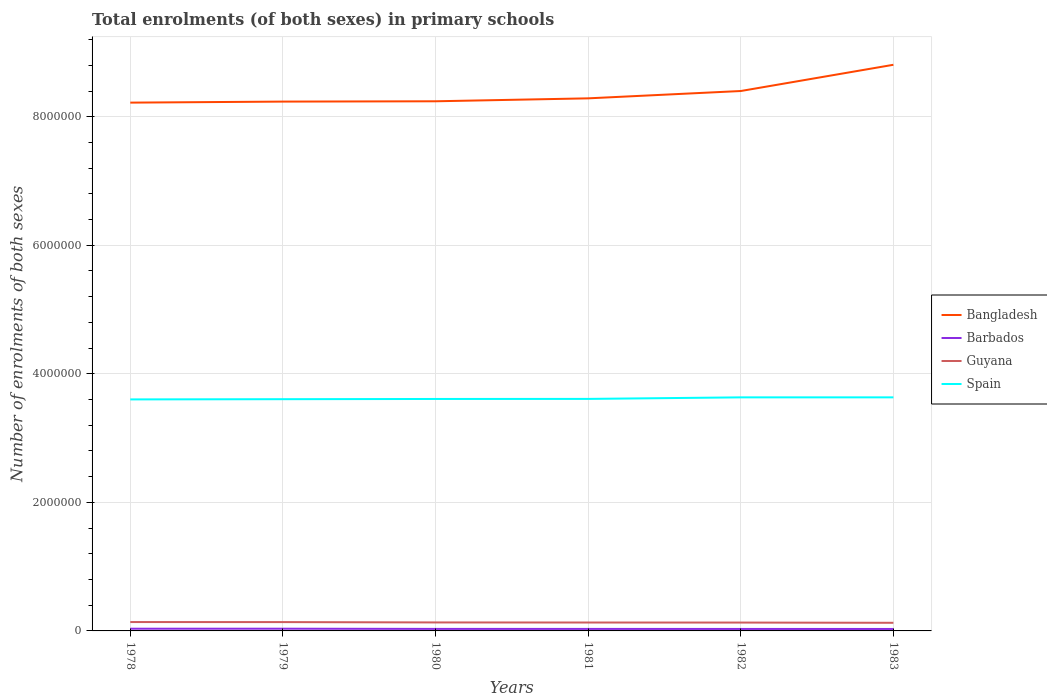Across all years, what is the maximum number of enrolments in primary schools in Spain?
Offer a terse response. 3.60e+06. In which year was the number of enrolments in primary schools in Barbados maximum?
Offer a very short reply. 1983. What is the total number of enrolments in primary schools in Barbados in the graph?
Offer a terse response. 810. What is the difference between the highest and the second highest number of enrolments in primary schools in Spain?
Keep it short and to the point. 3.20e+04. What is the difference between the highest and the lowest number of enrolments in primary schools in Barbados?
Offer a very short reply. 2. How many lines are there?
Provide a succinct answer. 4. How many years are there in the graph?
Your response must be concise. 6. What is the difference between two consecutive major ticks on the Y-axis?
Keep it short and to the point. 2.00e+06. Where does the legend appear in the graph?
Offer a very short reply. Center right. How are the legend labels stacked?
Keep it short and to the point. Vertical. What is the title of the graph?
Offer a very short reply. Total enrolments (of both sexes) in primary schools. Does "Myanmar" appear as one of the legend labels in the graph?
Your answer should be very brief. No. What is the label or title of the Y-axis?
Your answer should be compact. Number of enrolments of both sexes. What is the Number of enrolments of both sexes in Bangladesh in 1978?
Provide a succinct answer. 8.22e+06. What is the Number of enrolments of both sexes in Barbados in 1978?
Give a very brief answer. 3.43e+04. What is the Number of enrolments of both sexes of Guyana in 1978?
Keep it short and to the point. 1.38e+05. What is the Number of enrolments of both sexes in Spain in 1978?
Your answer should be very brief. 3.60e+06. What is the Number of enrolments of both sexes in Bangladesh in 1979?
Your answer should be very brief. 8.24e+06. What is the Number of enrolments of both sexes in Barbados in 1979?
Make the answer very short. 3.45e+04. What is the Number of enrolments of both sexes of Guyana in 1979?
Your response must be concise. 1.37e+05. What is the Number of enrolments of both sexes in Spain in 1979?
Offer a very short reply. 3.61e+06. What is the Number of enrolments of both sexes of Bangladesh in 1980?
Keep it short and to the point. 8.24e+06. What is the Number of enrolments of both sexes in Barbados in 1980?
Offer a terse response. 3.13e+04. What is the Number of enrolments of both sexes in Guyana in 1980?
Give a very brief answer. 1.32e+05. What is the Number of enrolments of both sexes in Spain in 1980?
Offer a terse response. 3.61e+06. What is the Number of enrolments of both sexes in Bangladesh in 1981?
Provide a short and direct response. 8.29e+06. What is the Number of enrolments of both sexes of Barbados in 1981?
Keep it short and to the point. 3.11e+04. What is the Number of enrolments of both sexes in Guyana in 1981?
Ensure brevity in your answer.  1.31e+05. What is the Number of enrolments of both sexes of Spain in 1981?
Keep it short and to the point. 3.61e+06. What is the Number of enrolments of both sexes in Bangladesh in 1982?
Your response must be concise. 8.40e+06. What is the Number of enrolments of both sexes in Barbados in 1982?
Keep it short and to the point. 3.07e+04. What is the Number of enrolments of both sexes of Guyana in 1982?
Provide a succinct answer. 1.30e+05. What is the Number of enrolments of both sexes in Spain in 1982?
Make the answer very short. 3.63e+06. What is the Number of enrolments of both sexes in Bangladesh in 1983?
Provide a succinct answer. 8.81e+06. What is the Number of enrolments of both sexes in Barbados in 1983?
Offer a very short reply. 3.03e+04. What is the Number of enrolments of both sexes in Guyana in 1983?
Keep it short and to the point. 1.26e+05. What is the Number of enrolments of both sexes in Spain in 1983?
Provide a succinct answer. 3.63e+06. Across all years, what is the maximum Number of enrolments of both sexes in Bangladesh?
Make the answer very short. 8.81e+06. Across all years, what is the maximum Number of enrolments of both sexes in Barbados?
Make the answer very short. 3.45e+04. Across all years, what is the maximum Number of enrolments of both sexes of Guyana?
Keep it short and to the point. 1.38e+05. Across all years, what is the maximum Number of enrolments of both sexes of Spain?
Give a very brief answer. 3.63e+06. Across all years, what is the minimum Number of enrolments of both sexes in Bangladesh?
Make the answer very short. 8.22e+06. Across all years, what is the minimum Number of enrolments of both sexes in Barbados?
Provide a short and direct response. 3.03e+04. Across all years, what is the minimum Number of enrolments of both sexes in Guyana?
Offer a terse response. 1.26e+05. Across all years, what is the minimum Number of enrolments of both sexes of Spain?
Your answer should be very brief. 3.60e+06. What is the total Number of enrolments of both sexes of Bangladesh in the graph?
Provide a short and direct response. 5.02e+07. What is the total Number of enrolments of both sexes in Barbados in the graph?
Offer a very short reply. 1.92e+05. What is the total Number of enrolments of both sexes in Guyana in the graph?
Your answer should be compact. 7.95e+05. What is the total Number of enrolments of both sexes in Spain in the graph?
Offer a very short reply. 2.17e+07. What is the difference between the Number of enrolments of both sexes of Bangladesh in 1978 and that in 1979?
Keep it short and to the point. -1.59e+04. What is the difference between the Number of enrolments of both sexes in Barbados in 1978 and that in 1979?
Offer a terse response. -212. What is the difference between the Number of enrolments of both sexes in Guyana in 1978 and that in 1979?
Keep it short and to the point. 832. What is the difference between the Number of enrolments of both sexes of Spain in 1978 and that in 1979?
Your answer should be very brief. -3376. What is the difference between the Number of enrolments of both sexes in Bangladesh in 1978 and that in 1980?
Your response must be concise. -2.09e+04. What is the difference between the Number of enrolments of both sexes in Barbados in 1978 and that in 1980?
Ensure brevity in your answer.  3025. What is the difference between the Number of enrolments of both sexes of Guyana in 1978 and that in 1980?
Offer a terse response. 6069. What is the difference between the Number of enrolments of both sexes in Spain in 1978 and that in 1980?
Your answer should be compact. -6906. What is the difference between the Number of enrolments of both sexes of Bangladesh in 1978 and that in 1981?
Your response must be concise. -6.65e+04. What is the difference between the Number of enrolments of both sexes of Barbados in 1978 and that in 1981?
Your answer should be very brief. 3177. What is the difference between the Number of enrolments of both sexes in Guyana in 1978 and that in 1981?
Offer a very short reply. 7312. What is the difference between the Number of enrolments of both sexes of Spain in 1978 and that in 1981?
Your answer should be compact. -7675. What is the difference between the Number of enrolments of both sexes of Bangladesh in 1978 and that in 1982?
Your response must be concise. -1.81e+05. What is the difference between the Number of enrolments of both sexes of Barbados in 1978 and that in 1982?
Your answer should be very brief. 3596. What is the difference between the Number of enrolments of both sexes of Guyana in 1978 and that in 1982?
Make the answer very short. 8141. What is the difference between the Number of enrolments of both sexes of Spain in 1978 and that in 1982?
Your response must be concise. -3.18e+04. What is the difference between the Number of enrolments of both sexes in Bangladesh in 1978 and that in 1983?
Provide a short and direct response. -5.89e+05. What is the difference between the Number of enrolments of both sexes in Barbados in 1978 and that in 1983?
Offer a terse response. 3987. What is the difference between the Number of enrolments of both sexes of Guyana in 1978 and that in 1983?
Provide a short and direct response. 1.18e+04. What is the difference between the Number of enrolments of both sexes of Spain in 1978 and that in 1983?
Make the answer very short. -3.20e+04. What is the difference between the Number of enrolments of both sexes of Bangladesh in 1979 and that in 1980?
Ensure brevity in your answer.  -4932. What is the difference between the Number of enrolments of both sexes in Barbados in 1979 and that in 1980?
Offer a terse response. 3237. What is the difference between the Number of enrolments of both sexes of Guyana in 1979 and that in 1980?
Provide a succinct answer. 5237. What is the difference between the Number of enrolments of both sexes of Spain in 1979 and that in 1980?
Offer a very short reply. -3530. What is the difference between the Number of enrolments of both sexes of Bangladesh in 1979 and that in 1981?
Provide a succinct answer. -5.06e+04. What is the difference between the Number of enrolments of both sexes in Barbados in 1979 and that in 1981?
Your answer should be very brief. 3389. What is the difference between the Number of enrolments of both sexes in Guyana in 1979 and that in 1981?
Your answer should be compact. 6480. What is the difference between the Number of enrolments of both sexes of Spain in 1979 and that in 1981?
Give a very brief answer. -4299. What is the difference between the Number of enrolments of both sexes of Bangladesh in 1979 and that in 1982?
Your answer should be compact. -1.65e+05. What is the difference between the Number of enrolments of both sexes of Barbados in 1979 and that in 1982?
Provide a succinct answer. 3808. What is the difference between the Number of enrolments of both sexes in Guyana in 1979 and that in 1982?
Ensure brevity in your answer.  7309. What is the difference between the Number of enrolments of both sexes in Spain in 1979 and that in 1982?
Give a very brief answer. -2.84e+04. What is the difference between the Number of enrolments of both sexes in Bangladesh in 1979 and that in 1983?
Your answer should be compact. -5.73e+05. What is the difference between the Number of enrolments of both sexes of Barbados in 1979 and that in 1983?
Your answer should be very brief. 4199. What is the difference between the Number of enrolments of both sexes in Guyana in 1979 and that in 1983?
Your answer should be very brief. 1.09e+04. What is the difference between the Number of enrolments of both sexes of Spain in 1979 and that in 1983?
Your answer should be very brief. -2.86e+04. What is the difference between the Number of enrolments of both sexes of Bangladesh in 1980 and that in 1981?
Provide a succinct answer. -4.56e+04. What is the difference between the Number of enrolments of both sexes of Barbados in 1980 and that in 1981?
Give a very brief answer. 152. What is the difference between the Number of enrolments of both sexes of Guyana in 1980 and that in 1981?
Offer a terse response. 1243. What is the difference between the Number of enrolments of both sexes of Spain in 1980 and that in 1981?
Provide a succinct answer. -769. What is the difference between the Number of enrolments of both sexes of Bangladesh in 1980 and that in 1982?
Keep it short and to the point. -1.60e+05. What is the difference between the Number of enrolments of both sexes in Barbados in 1980 and that in 1982?
Make the answer very short. 571. What is the difference between the Number of enrolments of both sexes in Guyana in 1980 and that in 1982?
Ensure brevity in your answer.  2072. What is the difference between the Number of enrolments of both sexes in Spain in 1980 and that in 1982?
Give a very brief answer. -2.49e+04. What is the difference between the Number of enrolments of both sexes in Bangladesh in 1980 and that in 1983?
Offer a very short reply. -5.68e+05. What is the difference between the Number of enrolments of both sexes of Barbados in 1980 and that in 1983?
Your response must be concise. 962. What is the difference between the Number of enrolments of both sexes of Guyana in 1980 and that in 1983?
Offer a very short reply. 5703. What is the difference between the Number of enrolments of both sexes in Spain in 1980 and that in 1983?
Your response must be concise. -2.51e+04. What is the difference between the Number of enrolments of both sexes in Bangladesh in 1981 and that in 1982?
Ensure brevity in your answer.  -1.14e+05. What is the difference between the Number of enrolments of both sexes of Barbados in 1981 and that in 1982?
Offer a very short reply. 419. What is the difference between the Number of enrolments of both sexes in Guyana in 1981 and that in 1982?
Keep it short and to the point. 829. What is the difference between the Number of enrolments of both sexes of Spain in 1981 and that in 1982?
Provide a succinct answer. -2.41e+04. What is the difference between the Number of enrolments of both sexes of Bangladesh in 1981 and that in 1983?
Make the answer very short. -5.22e+05. What is the difference between the Number of enrolments of both sexes in Barbados in 1981 and that in 1983?
Provide a short and direct response. 810. What is the difference between the Number of enrolments of both sexes of Guyana in 1981 and that in 1983?
Make the answer very short. 4460. What is the difference between the Number of enrolments of both sexes of Spain in 1981 and that in 1983?
Your response must be concise. -2.43e+04. What is the difference between the Number of enrolments of both sexes of Bangladesh in 1982 and that in 1983?
Keep it short and to the point. -4.08e+05. What is the difference between the Number of enrolments of both sexes in Barbados in 1982 and that in 1983?
Make the answer very short. 391. What is the difference between the Number of enrolments of both sexes of Guyana in 1982 and that in 1983?
Provide a short and direct response. 3631. What is the difference between the Number of enrolments of both sexes in Spain in 1982 and that in 1983?
Keep it short and to the point. -193. What is the difference between the Number of enrolments of both sexes of Bangladesh in 1978 and the Number of enrolments of both sexes of Barbados in 1979?
Keep it short and to the point. 8.18e+06. What is the difference between the Number of enrolments of both sexes of Bangladesh in 1978 and the Number of enrolments of both sexes of Guyana in 1979?
Offer a very short reply. 8.08e+06. What is the difference between the Number of enrolments of both sexes in Bangladesh in 1978 and the Number of enrolments of both sexes in Spain in 1979?
Give a very brief answer. 4.61e+06. What is the difference between the Number of enrolments of both sexes of Barbados in 1978 and the Number of enrolments of both sexes of Guyana in 1979?
Give a very brief answer. -1.03e+05. What is the difference between the Number of enrolments of both sexes in Barbados in 1978 and the Number of enrolments of both sexes in Spain in 1979?
Offer a terse response. -3.57e+06. What is the difference between the Number of enrolments of both sexes in Guyana in 1978 and the Number of enrolments of both sexes in Spain in 1979?
Give a very brief answer. -3.47e+06. What is the difference between the Number of enrolments of both sexes in Bangladesh in 1978 and the Number of enrolments of both sexes in Barbados in 1980?
Keep it short and to the point. 8.19e+06. What is the difference between the Number of enrolments of both sexes in Bangladesh in 1978 and the Number of enrolments of both sexes in Guyana in 1980?
Provide a succinct answer. 8.09e+06. What is the difference between the Number of enrolments of both sexes of Bangladesh in 1978 and the Number of enrolments of both sexes of Spain in 1980?
Give a very brief answer. 4.61e+06. What is the difference between the Number of enrolments of both sexes in Barbados in 1978 and the Number of enrolments of both sexes in Guyana in 1980?
Provide a short and direct response. -9.78e+04. What is the difference between the Number of enrolments of both sexes of Barbados in 1978 and the Number of enrolments of both sexes of Spain in 1980?
Ensure brevity in your answer.  -3.57e+06. What is the difference between the Number of enrolments of both sexes of Guyana in 1978 and the Number of enrolments of both sexes of Spain in 1980?
Ensure brevity in your answer.  -3.47e+06. What is the difference between the Number of enrolments of both sexes in Bangladesh in 1978 and the Number of enrolments of both sexes in Barbados in 1981?
Keep it short and to the point. 8.19e+06. What is the difference between the Number of enrolments of both sexes of Bangladesh in 1978 and the Number of enrolments of both sexes of Guyana in 1981?
Your answer should be compact. 8.09e+06. What is the difference between the Number of enrolments of both sexes of Bangladesh in 1978 and the Number of enrolments of both sexes of Spain in 1981?
Your answer should be very brief. 4.61e+06. What is the difference between the Number of enrolments of both sexes in Barbados in 1978 and the Number of enrolments of both sexes in Guyana in 1981?
Ensure brevity in your answer.  -9.65e+04. What is the difference between the Number of enrolments of both sexes in Barbados in 1978 and the Number of enrolments of both sexes in Spain in 1981?
Provide a short and direct response. -3.58e+06. What is the difference between the Number of enrolments of both sexes of Guyana in 1978 and the Number of enrolments of both sexes of Spain in 1981?
Your answer should be very brief. -3.47e+06. What is the difference between the Number of enrolments of both sexes of Bangladesh in 1978 and the Number of enrolments of both sexes of Barbados in 1982?
Your answer should be very brief. 8.19e+06. What is the difference between the Number of enrolments of both sexes of Bangladesh in 1978 and the Number of enrolments of both sexes of Guyana in 1982?
Keep it short and to the point. 8.09e+06. What is the difference between the Number of enrolments of both sexes in Bangladesh in 1978 and the Number of enrolments of both sexes in Spain in 1982?
Offer a very short reply. 4.59e+06. What is the difference between the Number of enrolments of both sexes in Barbados in 1978 and the Number of enrolments of both sexes in Guyana in 1982?
Your response must be concise. -9.57e+04. What is the difference between the Number of enrolments of both sexes of Barbados in 1978 and the Number of enrolments of both sexes of Spain in 1982?
Offer a terse response. -3.60e+06. What is the difference between the Number of enrolments of both sexes in Guyana in 1978 and the Number of enrolments of both sexes in Spain in 1982?
Provide a succinct answer. -3.50e+06. What is the difference between the Number of enrolments of both sexes of Bangladesh in 1978 and the Number of enrolments of both sexes of Barbados in 1983?
Give a very brief answer. 8.19e+06. What is the difference between the Number of enrolments of both sexes in Bangladesh in 1978 and the Number of enrolments of both sexes in Guyana in 1983?
Your answer should be compact. 8.09e+06. What is the difference between the Number of enrolments of both sexes of Bangladesh in 1978 and the Number of enrolments of both sexes of Spain in 1983?
Offer a terse response. 4.59e+06. What is the difference between the Number of enrolments of both sexes in Barbados in 1978 and the Number of enrolments of both sexes in Guyana in 1983?
Your answer should be very brief. -9.20e+04. What is the difference between the Number of enrolments of both sexes in Barbados in 1978 and the Number of enrolments of both sexes in Spain in 1983?
Your answer should be compact. -3.60e+06. What is the difference between the Number of enrolments of both sexes in Guyana in 1978 and the Number of enrolments of both sexes in Spain in 1983?
Offer a terse response. -3.50e+06. What is the difference between the Number of enrolments of both sexes in Bangladesh in 1979 and the Number of enrolments of both sexes in Barbados in 1980?
Offer a very short reply. 8.20e+06. What is the difference between the Number of enrolments of both sexes in Bangladesh in 1979 and the Number of enrolments of both sexes in Guyana in 1980?
Provide a short and direct response. 8.10e+06. What is the difference between the Number of enrolments of both sexes in Bangladesh in 1979 and the Number of enrolments of both sexes in Spain in 1980?
Your answer should be compact. 4.63e+06. What is the difference between the Number of enrolments of both sexes in Barbados in 1979 and the Number of enrolments of both sexes in Guyana in 1980?
Offer a terse response. -9.75e+04. What is the difference between the Number of enrolments of both sexes of Barbados in 1979 and the Number of enrolments of both sexes of Spain in 1980?
Your answer should be very brief. -3.57e+06. What is the difference between the Number of enrolments of both sexes in Guyana in 1979 and the Number of enrolments of both sexes in Spain in 1980?
Provide a succinct answer. -3.47e+06. What is the difference between the Number of enrolments of both sexes of Bangladesh in 1979 and the Number of enrolments of both sexes of Barbados in 1981?
Your response must be concise. 8.20e+06. What is the difference between the Number of enrolments of both sexes of Bangladesh in 1979 and the Number of enrolments of both sexes of Guyana in 1981?
Your answer should be very brief. 8.10e+06. What is the difference between the Number of enrolments of both sexes in Bangladesh in 1979 and the Number of enrolments of both sexes in Spain in 1981?
Your answer should be very brief. 4.63e+06. What is the difference between the Number of enrolments of both sexes in Barbados in 1979 and the Number of enrolments of both sexes in Guyana in 1981?
Give a very brief answer. -9.63e+04. What is the difference between the Number of enrolments of both sexes in Barbados in 1979 and the Number of enrolments of both sexes in Spain in 1981?
Provide a short and direct response. -3.58e+06. What is the difference between the Number of enrolments of both sexes of Guyana in 1979 and the Number of enrolments of both sexes of Spain in 1981?
Offer a very short reply. -3.47e+06. What is the difference between the Number of enrolments of both sexes of Bangladesh in 1979 and the Number of enrolments of both sexes of Barbados in 1982?
Offer a very short reply. 8.20e+06. What is the difference between the Number of enrolments of both sexes of Bangladesh in 1979 and the Number of enrolments of both sexes of Guyana in 1982?
Your answer should be compact. 8.11e+06. What is the difference between the Number of enrolments of both sexes of Bangladesh in 1979 and the Number of enrolments of both sexes of Spain in 1982?
Provide a short and direct response. 4.60e+06. What is the difference between the Number of enrolments of both sexes in Barbados in 1979 and the Number of enrolments of both sexes in Guyana in 1982?
Offer a very short reply. -9.55e+04. What is the difference between the Number of enrolments of both sexes in Barbados in 1979 and the Number of enrolments of both sexes in Spain in 1982?
Give a very brief answer. -3.60e+06. What is the difference between the Number of enrolments of both sexes in Guyana in 1979 and the Number of enrolments of both sexes in Spain in 1982?
Ensure brevity in your answer.  -3.50e+06. What is the difference between the Number of enrolments of both sexes of Bangladesh in 1979 and the Number of enrolments of both sexes of Barbados in 1983?
Your answer should be compact. 8.20e+06. What is the difference between the Number of enrolments of both sexes in Bangladesh in 1979 and the Number of enrolments of both sexes in Guyana in 1983?
Your response must be concise. 8.11e+06. What is the difference between the Number of enrolments of both sexes in Bangladesh in 1979 and the Number of enrolments of both sexes in Spain in 1983?
Offer a terse response. 4.60e+06. What is the difference between the Number of enrolments of both sexes in Barbados in 1979 and the Number of enrolments of both sexes in Guyana in 1983?
Ensure brevity in your answer.  -9.18e+04. What is the difference between the Number of enrolments of both sexes in Barbados in 1979 and the Number of enrolments of both sexes in Spain in 1983?
Keep it short and to the point. -3.60e+06. What is the difference between the Number of enrolments of both sexes in Guyana in 1979 and the Number of enrolments of both sexes in Spain in 1983?
Your answer should be very brief. -3.50e+06. What is the difference between the Number of enrolments of both sexes in Bangladesh in 1980 and the Number of enrolments of both sexes in Barbados in 1981?
Provide a short and direct response. 8.21e+06. What is the difference between the Number of enrolments of both sexes of Bangladesh in 1980 and the Number of enrolments of both sexes of Guyana in 1981?
Your answer should be compact. 8.11e+06. What is the difference between the Number of enrolments of both sexes of Bangladesh in 1980 and the Number of enrolments of both sexes of Spain in 1981?
Your answer should be very brief. 4.63e+06. What is the difference between the Number of enrolments of both sexes of Barbados in 1980 and the Number of enrolments of both sexes of Guyana in 1981?
Make the answer very short. -9.95e+04. What is the difference between the Number of enrolments of both sexes in Barbados in 1980 and the Number of enrolments of both sexes in Spain in 1981?
Provide a short and direct response. -3.58e+06. What is the difference between the Number of enrolments of both sexes of Guyana in 1980 and the Number of enrolments of both sexes of Spain in 1981?
Your answer should be compact. -3.48e+06. What is the difference between the Number of enrolments of both sexes of Bangladesh in 1980 and the Number of enrolments of both sexes of Barbados in 1982?
Your answer should be compact. 8.21e+06. What is the difference between the Number of enrolments of both sexes in Bangladesh in 1980 and the Number of enrolments of both sexes in Guyana in 1982?
Give a very brief answer. 8.11e+06. What is the difference between the Number of enrolments of both sexes in Bangladesh in 1980 and the Number of enrolments of both sexes in Spain in 1982?
Make the answer very short. 4.61e+06. What is the difference between the Number of enrolments of both sexes of Barbados in 1980 and the Number of enrolments of both sexes of Guyana in 1982?
Give a very brief answer. -9.87e+04. What is the difference between the Number of enrolments of both sexes of Barbados in 1980 and the Number of enrolments of both sexes of Spain in 1982?
Provide a short and direct response. -3.60e+06. What is the difference between the Number of enrolments of both sexes in Guyana in 1980 and the Number of enrolments of both sexes in Spain in 1982?
Provide a short and direct response. -3.50e+06. What is the difference between the Number of enrolments of both sexes of Bangladesh in 1980 and the Number of enrolments of both sexes of Barbados in 1983?
Ensure brevity in your answer.  8.21e+06. What is the difference between the Number of enrolments of both sexes of Bangladesh in 1980 and the Number of enrolments of both sexes of Guyana in 1983?
Ensure brevity in your answer.  8.11e+06. What is the difference between the Number of enrolments of both sexes in Bangladesh in 1980 and the Number of enrolments of both sexes in Spain in 1983?
Offer a terse response. 4.61e+06. What is the difference between the Number of enrolments of both sexes in Barbados in 1980 and the Number of enrolments of both sexes in Guyana in 1983?
Provide a succinct answer. -9.51e+04. What is the difference between the Number of enrolments of both sexes in Barbados in 1980 and the Number of enrolments of both sexes in Spain in 1983?
Your answer should be compact. -3.60e+06. What is the difference between the Number of enrolments of both sexes of Guyana in 1980 and the Number of enrolments of both sexes of Spain in 1983?
Offer a very short reply. -3.50e+06. What is the difference between the Number of enrolments of both sexes in Bangladesh in 1981 and the Number of enrolments of both sexes in Barbados in 1982?
Your response must be concise. 8.26e+06. What is the difference between the Number of enrolments of both sexes in Bangladesh in 1981 and the Number of enrolments of both sexes in Guyana in 1982?
Offer a terse response. 8.16e+06. What is the difference between the Number of enrolments of both sexes of Bangladesh in 1981 and the Number of enrolments of both sexes of Spain in 1982?
Your answer should be compact. 4.65e+06. What is the difference between the Number of enrolments of both sexes in Barbados in 1981 and the Number of enrolments of both sexes in Guyana in 1982?
Your answer should be very brief. -9.89e+04. What is the difference between the Number of enrolments of both sexes of Barbados in 1981 and the Number of enrolments of both sexes of Spain in 1982?
Offer a very short reply. -3.60e+06. What is the difference between the Number of enrolments of both sexes of Guyana in 1981 and the Number of enrolments of both sexes of Spain in 1982?
Make the answer very short. -3.50e+06. What is the difference between the Number of enrolments of both sexes of Bangladesh in 1981 and the Number of enrolments of both sexes of Barbados in 1983?
Provide a short and direct response. 8.26e+06. What is the difference between the Number of enrolments of both sexes in Bangladesh in 1981 and the Number of enrolments of both sexes in Guyana in 1983?
Give a very brief answer. 8.16e+06. What is the difference between the Number of enrolments of both sexes in Bangladesh in 1981 and the Number of enrolments of both sexes in Spain in 1983?
Keep it short and to the point. 4.65e+06. What is the difference between the Number of enrolments of both sexes in Barbados in 1981 and the Number of enrolments of both sexes in Guyana in 1983?
Make the answer very short. -9.52e+04. What is the difference between the Number of enrolments of both sexes of Barbados in 1981 and the Number of enrolments of both sexes of Spain in 1983?
Your answer should be compact. -3.60e+06. What is the difference between the Number of enrolments of both sexes of Guyana in 1981 and the Number of enrolments of both sexes of Spain in 1983?
Make the answer very short. -3.50e+06. What is the difference between the Number of enrolments of both sexes in Bangladesh in 1982 and the Number of enrolments of both sexes in Barbados in 1983?
Your answer should be compact. 8.37e+06. What is the difference between the Number of enrolments of both sexes of Bangladesh in 1982 and the Number of enrolments of both sexes of Guyana in 1983?
Keep it short and to the point. 8.27e+06. What is the difference between the Number of enrolments of both sexes in Bangladesh in 1982 and the Number of enrolments of both sexes in Spain in 1983?
Keep it short and to the point. 4.77e+06. What is the difference between the Number of enrolments of both sexes in Barbados in 1982 and the Number of enrolments of both sexes in Guyana in 1983?
Keep it short and to the point. -9.56e+04. What is the difference between the Number of enrolments of both sexes in Barbados in 1982 and the Number of enrolments of both sexes in Spain in 1983?
Keep it short and to the point. -3.60e+06. What is the difference between the Number of enrolments of both sexes of Guyana in 1982 and the Number of enrolments of both sexes of Spain in 1983?
Make the answer very short. -3.50e+06. What is the average Number of enrolments of both sexes in Bangladesh per year?
Give a very brief answer. 8.36e+06. What is the average Number of enrolments of both sexes in Barbados per year?
Offer a terse response. 3.21e+04. What is the average Number of enrolments of both sexes of Guyana per year?
Provide a succinct answer. 1.32e+05. What is the average Number of enrolments of both sexes in Spain per year?
Provide a short and direct response. 3.62e+06. In the year 1978, what is the difference between the Number of enrolments of both sexes of Bangladesh and Number of enrolments of both sexes of Barbados?
Ensure brevity in your answer.  8.18e+06. In the year 1978, what is the difference between the Number of enrolments of both sexes in Bangladesh and Number of enrolments of both sexes in Guyana?
Keep it short and to the point. 8.08e+06. In the year 1978, what is the difference between the Number of enrolments of both sexes of Bangladesh and Number of enrolments of both sexes of Spain?
Offer a very short reply. 4.62e+06. In the year 1978, what is the difference between the Number of enrolments of both sexes of Barbados and Number of enrolments of both sexes of Guyana?
Your response must be concise. -1.04e+05. In the year 1978, what is the difference between the Number of enrolments of both sexes in Barbados and Number of enrolments of both sexes in Spain?
Provide a succinct answer. -3.57e+06. In the year 1978, what is the difference between the Number of enrolments of both sexes of Guyana and Number of enrolments of both sexes of Spain?
Your response must be concise. -3.46e+06. In the year 1979, what is the difference between the Number of enrolments of both sexes in Bangladesh and Number of enrolments of both sexes in Barbados?
Your answer should be very brief. 8.20e+06. In the year 1979, what is the difference between the Number of enrolments of both sexes of Bangladesh and Number of enrolments of both sexes of Guyana?
Give a very brief answer. 8.10e+06. In the year 1979, what is the difference between the Number of enrolments of both sexes of Bangladesh and Number of enrolments of both sexes of Spain?
Your answer should be compact. 4.63e+06. In the year 1979, what is the difference between the Number of enrolments of both sexes in Barbados and Number of enrolments of both sexes in Guyana?
Make the answer very short. -1.03e+05. In the year 1979, what is the difference between the Number of enrolments of both sexes of Barbados and Number of enrolments of both sexes of Spain?
Provide a short and direct response. -3.57e+06. In the year 1979, what is the difference between the Number of enrolments of both sexes in Guyana and Number of enrolments of both sexes in Spain?
Your response must be concise. -3.47e+06. In the year 1980, what is the difference between the Number of enrolments of both sexes in Bangladesh and Number of enrolments of both sexes in Barbados?
Your answer should be compact. 8.21e+06. In the year 1980, what is the difference between the Number of enrolments of both sexes in Bangladesh and Number of enrolments of both sexes in Guyana?
Give a very brief answer. 8.11e+06. In the year 1980, what is the difference between the Number of enrolments of both sexes in Bangladesh and Number of enrolments of both sexes in Spain?
Offer a terse response. 4.63e+06. In the year 1980, what is the difference between the Number of enrolments of both sexes in Barbados and Number of enrolments of both sexes in Guyana?
Your answer should be compact. -1.01e+05. In the year 1980, what is the difference between the Number of enrolments of both sexes of Barbados and Number of enrolments of both sexes of Spain?
Give a very brief answer. -3.58e+06. In the year 1980, what is the difference between the Number of enrolments of both sexes in Guyana and Number of enrolments of both sexes in Spain?
Give a very brief answer. -3.48e+06. In the year 1981, what is the difference between the Number of enrolments of both sexes in Bangladesh and Number of enrolments of both sexes in Barbados?
Provide a succinct answer. 8.25e+06. In the year 1981, what is the difference between the Number of enrolments of both sexes of Bangladesh and Number of enrolments of both sexes of Guyana?
Your answer should be very brief. 8.15e+06. In the year 1981, what is the difference between the Number of enrolments of both sexes of Bangladesh and Number of enrolments of both sexes of Spain?
Provide a short and direct response. 4.68e+06. In the year 1981, what is the difference between the Number of enrolments of both sexes in Barbados and Number of enrolments of both sexes in Guyana?
Provide a succinct answer. -9.97e+04. In the year 1981, what is the difference between the Number of enrolments of both sexes in Barbados and Number of enrolments of both sexes in Spain?
Provide a short and direct response. -3.58e+06. In the year 1981, what is the difference between the Number of enrolments of both sexes of Guyana and Number of enrolments of both sexes of Spain?
Your answer should be very brief. -3.48e+06. In the year 1982, what is the difference between the Number of enrolments of both sexes in Bangladesh and Number of enrolments of both sexes in Barbados?
Offer a very short reply. 8.37e+06. In the year 1982, what is the difference between the Number of enrolments of both sexes of Bangladesh and Number of enrolments of both sexes of Guyana?
Offer a very short reply. 8.27e+06. In the year 1982, what is the difference between the Number of enrolments of both sexes in Bangladesh and Number of enrolments of both sexes in Spain?
Your answer should be very brief. 4.77e+06. In the year 1982, what is the difference between the Number of enrolments of both sexes of Barbados and Number of enrolments of both sexes of Guyana?
Provide a short and direct response. -9.93e+04. In the year 1982, what is the difference between the Number of enrolments of both sexes in Barbados and Number of enrolments of both sexes in Spain?
Give a very brief answer. -3.60e+06. In the year 1982, what is the difference between the Number of enrolments of both sexes in Guyana and Number of enrolments of both sexes in Spain?
Provide a succinct answer. -3.50e+06. In the year 1983, what is the difference between the Number of enrolments of both sexes in Bangladesh and Number of enrolments of both sexes in Barbados?
Offer a terse response. 8.78e+06. In the year 1983, what is the difference between the Number of enrolments of both sexes in Bangladesh and Number of enrolments of both sexes in Guyana?
Provide a succinct answer. 8.68e+06. In the year 1983, what is the difference between the Number of enrolments of both sexes in Bangladesh and Number of enrolments of both sexes in Spain?
Provide a succinct answer. 5.17e+06. In the year 1983, what is the difference between the Number of enrolments of both sexes in Barbados and Number of enrolments of both sexes in Guyana?
Make the answer very short. -9.60e+04. In the year 1983, what is the difference between the Number of enrolments of both sexes in Barbados and Number of enrolments of both sexes in Spain?
Your answer should be compact. -3.60e+06. In the year 1983, what is the difference between the Number of enrolments of both sexes of Guyana and Number of enrolments of both sexes of Spain?
Make the answer very short. -3.51e+06. What is the ratio of the Number of enrolments of both sexes of Barbados in 1978 to that in 1979?
Give a very brief answer. 0.99. What is the ratio of the Number of enrolments of both sexes of Bangladesh in 1978 to that in 1980?
Your answer should be compact. 1. What is the ratio of the Number of enrolments of both sexes of Barbados in 1978 to that in 1980?
Ensure brevity in your answer.  1.1. What is the ratio of the Number of enrolments of both sexes in Guyana in 1978 to that in 1980?
Provide a succinct answer. 1.05. What is the ratio of the Number of enrolments of both sexes in Spain in 1978 to that in 1980?
Your answer should be compact. 1. What is the ratio of the Number of enrolments of both sexes of Barbados in 1978 to that in 1981?
Make the answer very short. 1.1. What is the ratio of the Number of enrolments of both sexes in Guyana in 1978 to that in 1981?
Make the answer very short. 1.06. What is the ratio of the Number of enrolments of both sexes of Bangladesh in 1978 to that in 1982?
Make the answer very short. 0.98. What is the ratio of the Number of enrolments of both sexes in Barbados in 1978 to that in 1982?
Ensure brevity in your answer.  1.12. What is the ratio of the Number of enrolments of both sexes in Guyana in 1978 to that in 1982?
Your response must be concise. 1.06. What is the ratio of the Number of enrolments of both sexes of Spain in 1978 to that in 1982?
Your answer should be very brief. 0.99. What is the ratio of the Number of enrolments of both sexes in Bangladesh in 1978 to that in 1983?
Your answer should be very brief. 0.93. What is the ratio of the Number of enrolments of both sexes of Barbados in 1978 to that in 1983?
Give a very brief answer. 1.13. What is the ratio of the Number of enrolments of both sexes of Guyana in 1978 to that in 1983?
Make the answer very short. 1.09. What is the ratio of the Number of enrolments of both sexes in Bangladesh in 1979 to that in 1980?
Give a very brief answer. 1. What is the ratio of the Number of enrolments of both sexes in Barbados in 1979 to that in 1980?
Give a very brief answer. 1.1. What is the ratio of the Number of enrolments of both sexes in Guyana in 1979 to that in 1980?
Make the answer very short. 1.04. What is the ratio of the Number of enrolments of both sexes of Barbados in 1979 to that in 1981?
Make the answer very short. 1.11. What is the ratio of the Number of enrolments of both sexes in Guyana in 1979 to that in 1981?
Your response must be concise. 1.05. What is the ratio of the Number of enrolments of both sexes in Bangladesh in 1979 to that in 1982?
Provide a succinct answer. 0.98. What is the ratio of the Number of enrolments of both sexes of Barbados in 1979 to that in 1982?
Ensure brevity in your answer.  1.12. What is the ratio of the Number of enrolments of both sexes in Guyana in 1979 to that in 1982?
Give a very brief answer. 1.06. What is the ratio of the Number of enrolments of both sexes of Spain in 1979 to that in 1982?
Provide a short and direct response. 0.99. What is the ratio of the Number of enrolments of both sexes of Bangladesh in 1979 to that in 1983?
Provide a short and direct response. 0.94. What is the ratio of the Number of enrolments of both sexes of Barbados in 1979 to that in 1983?
Keep it short and to the point. 1.14. What is the ratio of the Number of enrolments of both sexes of Guyana in 1979 to that in 1983?
Provide a succinct answer. 1.09. What is the ratio of the Number of enrolments of both sexes in Barbados in 1980 to that in 1981?
Provide a succinct answer. 1. What is the ratio of the Number of enrolments of both sexes of Guyana in 1980 to that in 1981?
Ensure brevity in your answer.  1.01. What is the ratio of the Number of enrolments of both sexes of Spain in 1980 to that in 1981?
Offer a very short reply. 1. What is the ratio of the Number of enrolments of both sexes in Barbados in 1980 to that in 1982?
Offer a very short reply. 1.02. What is the ratio of the Number of enrolments of both sexes in Guyana in 1980 to that in 1982?
Keep it short and to the point. 1.02. What is the ratio of the Number of enrolments of both sexes of Spain in 1980 to that in 1982?
Offer a very short reply. 0.99. What is the ratio of the Number of enrolments of both sexes in Bangladesh in 1980 to that in 1983?
Give a very brief answer. 0.94. What is the ratio of the Number of enrolments of both sexes of Barbados in 1980 to that in 1983?
Your answer should be very brief. 1.03. What is the ratio of the Number of enrolments of both sexes of Guyana in 1980 to that in 1983?
Keep it short and to the point. 1.05. What is the ratio of the Number of enrolments of both sexes of Spain in 1980 to that in 1983?
Your answer should be compact. 0.99. What is the ratio of the Number of enrolments of both sexes of Bangladesh in 1981 to that in 1982?
Offer a terse response. 0.99. What is the ratio of the Number of enrolments of both sexes of Barbados in 1981 to that in 1982?
Your answer should be very brief. 1.01. What is the ratio of the Number of enrolments of both sexes of Guyana in 1981 to that in 1982?
Provide a succinct answer. 1.01. What is the ratio of the Number of enrolments of both sexes of Bangladesh in 1981 to that in 1983?
Keep it short and to the point. 0.94. What is the ratio of the Number of enrolments of both sexes of Barbados in 1981 to that in 1983?
Give a very brief answer. 1.03. What is the ratio of the Number of enrolments of both sexes in Guyana in 1981 to that in 1983?
Provide a succinct answer. 1.04. What is the ratio of the Number of enrolments of both sexes of Spain in 1981 to that in 1983?
Your answer should be very brief. 0.99. What is the ratio of the Number of enrolments of both sexes of Bangladesh in 1982 to that in 1983?
Your answer should be compact. 0.95. What is the ratio of the Number of enrolments of both sexes of Barbados in 1982 to that in 1983?
Ensure brevity in your answer.  1.01. What is the ratio of the Number of enrolments of both sexes of Guyana in 1982 to that in 1983?
Make the answer very short. 1.03. What is the ratio of the Number of enrolments of both sexes in Spain in 1982 to that in 1983?
Your response must be concise. 1. What is the difference between the highest and the second highest Number of enrolments of both sexes of Bangladesh?
Provide a short and direct response. 4.08e+05. What is the difference between the highest and the second highest Number of enrolments of both sexes in Barbados?
Offer a very short reply. 212. What is the difference between the highest and the second highest Number of enrolments of both sexes in Guyana?
Ensure brevity in your answer.  832. What is the difference between the highest and the second highest Number of enrolments of both sexes in Spain?
Make the answer very short. 193. What is the difference between the highest and the lowest Number of enrolments of both sexes in Bangladesh?
Your response must be concise. 5.89e+05. What is the difference between the highest and the lowest Number of enrolments of both sexes of Barbados?
Make the answer very short. 4199. What is the difference between the highest and the lowest Number of enrolments of both sexes in Guyana?
Provide a succinct answer. 1.18e+04. What is the difference between the highest and the lowest Number of enrolments of both sexes in Spain?
Keep it short and to the point. 3.20e+04. 